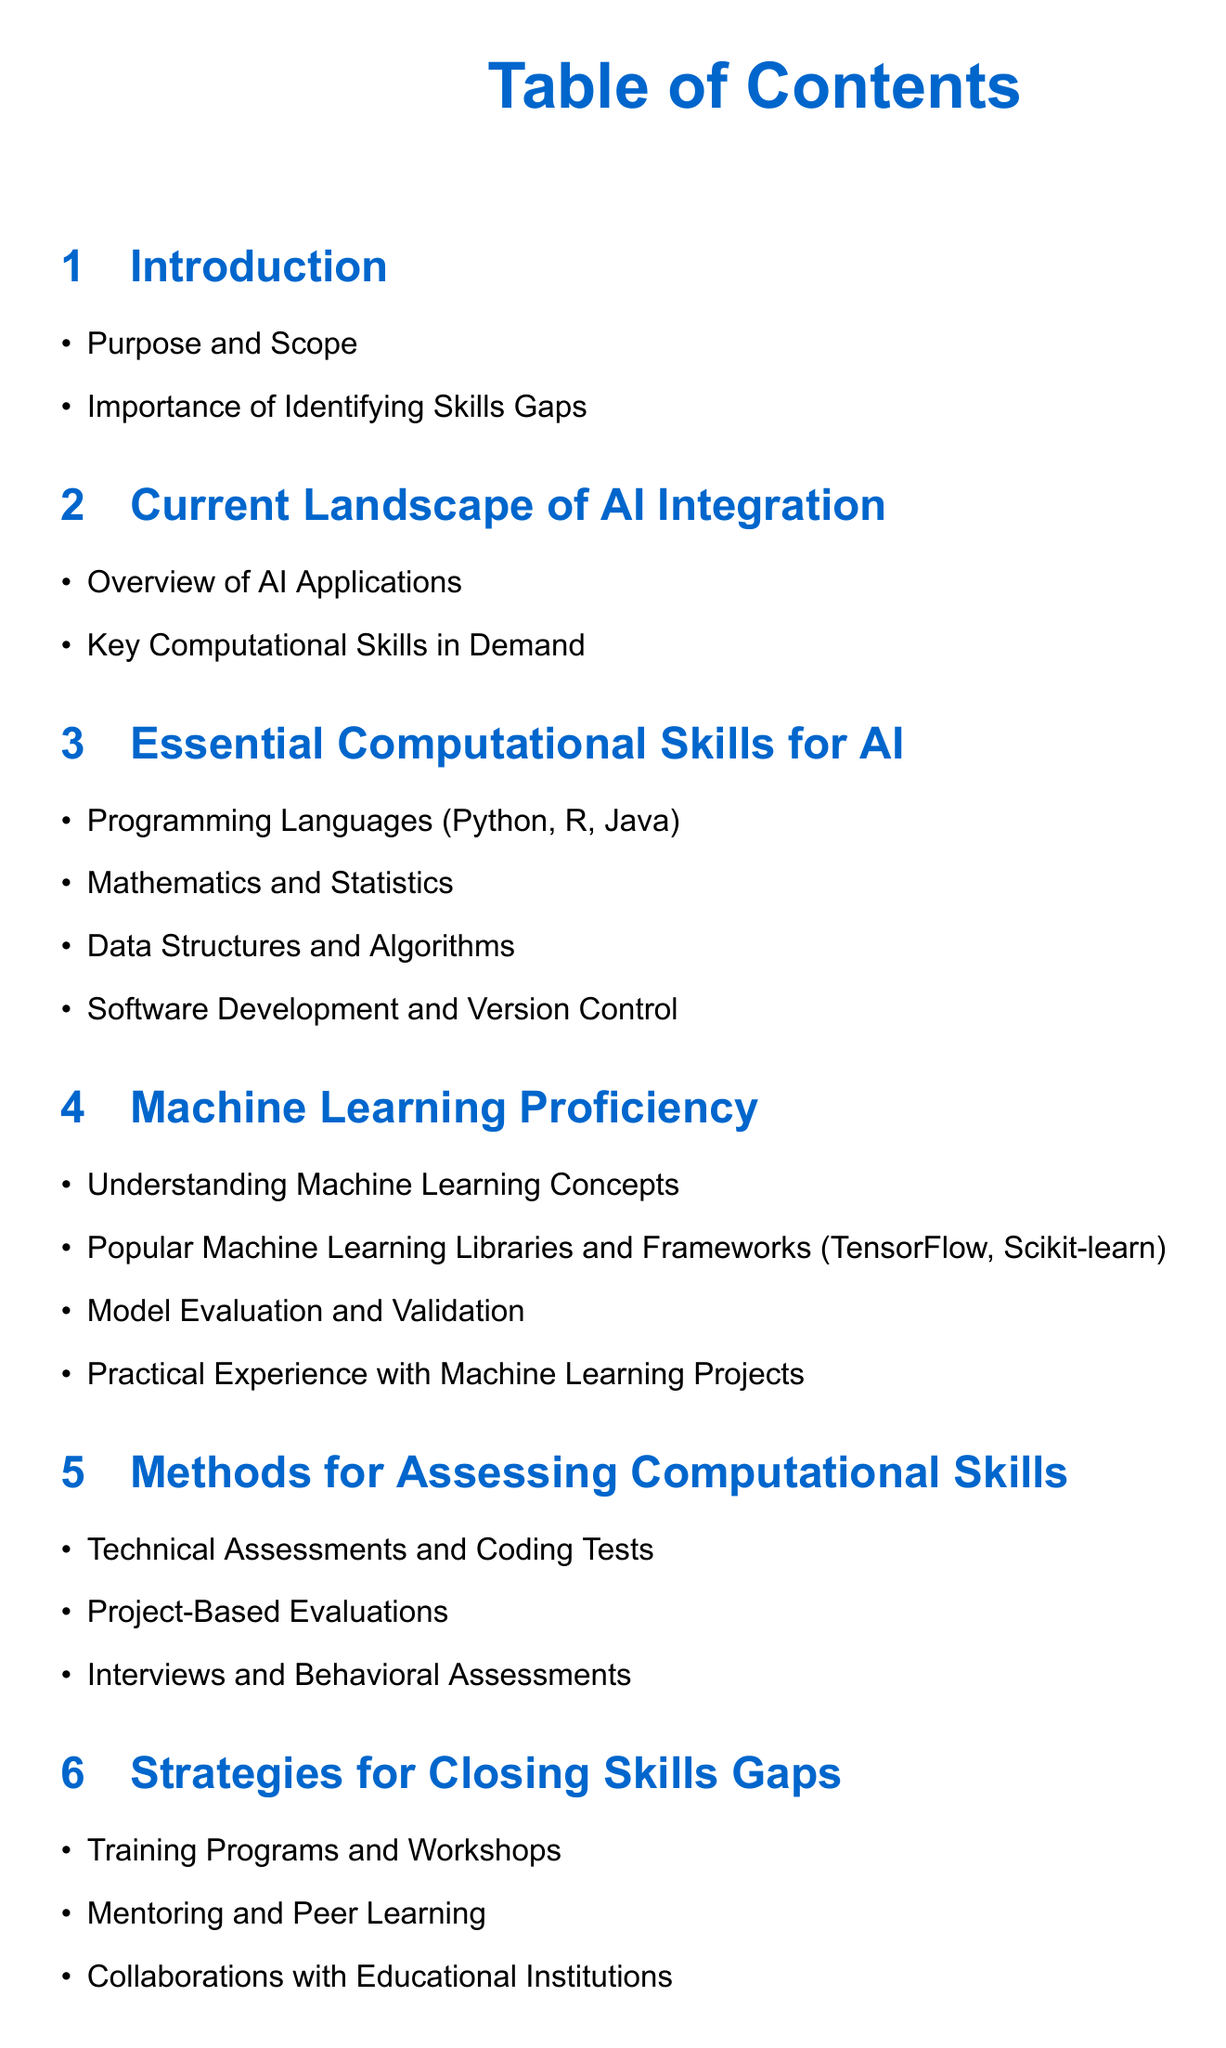What is the title of the document? The title of the document appears at the beginning of the Table of Contents.
Answer: Assessing Computational Skills and Machine Learning Proficiency How many essential computational skills are listed? The number of essential computational skills can be found in the relevant section of the Table of Contents.
Answer: Four Which programming languages are mentioned as essential skills? The specific programming languages are enumerated in the section about essential computational skills.
Answer: Python, R, Java What methods are suggested for assessing computational skills? The document lists methods for assessing skills in a dedicated section.
Answer: Technical Assessments and Coding Tests, Project-Based Evaluations, Interviews and Behavioral Assessments What is the conclusion section focused on? The conclusion section summarizes the key points and outlines the next steps for implementation.
Answer: Summary of Key Points, Roadmap for Implementation Name one popular machine learning library mentioned. The document specifies popular machine learning libraries in the relevant section.
Answer: TensorFlow Which strategy is mentioned for closing skills gaps? A strategy for addressing skills gaps is listed in the strategies section of the Table of Contents.
Answer: Training Programs and Workshops What is the purpose of identifying skills gaps? The purpose is explained in the introduction section of the document.
Answer: Importance of Identifying Skills Gaps 